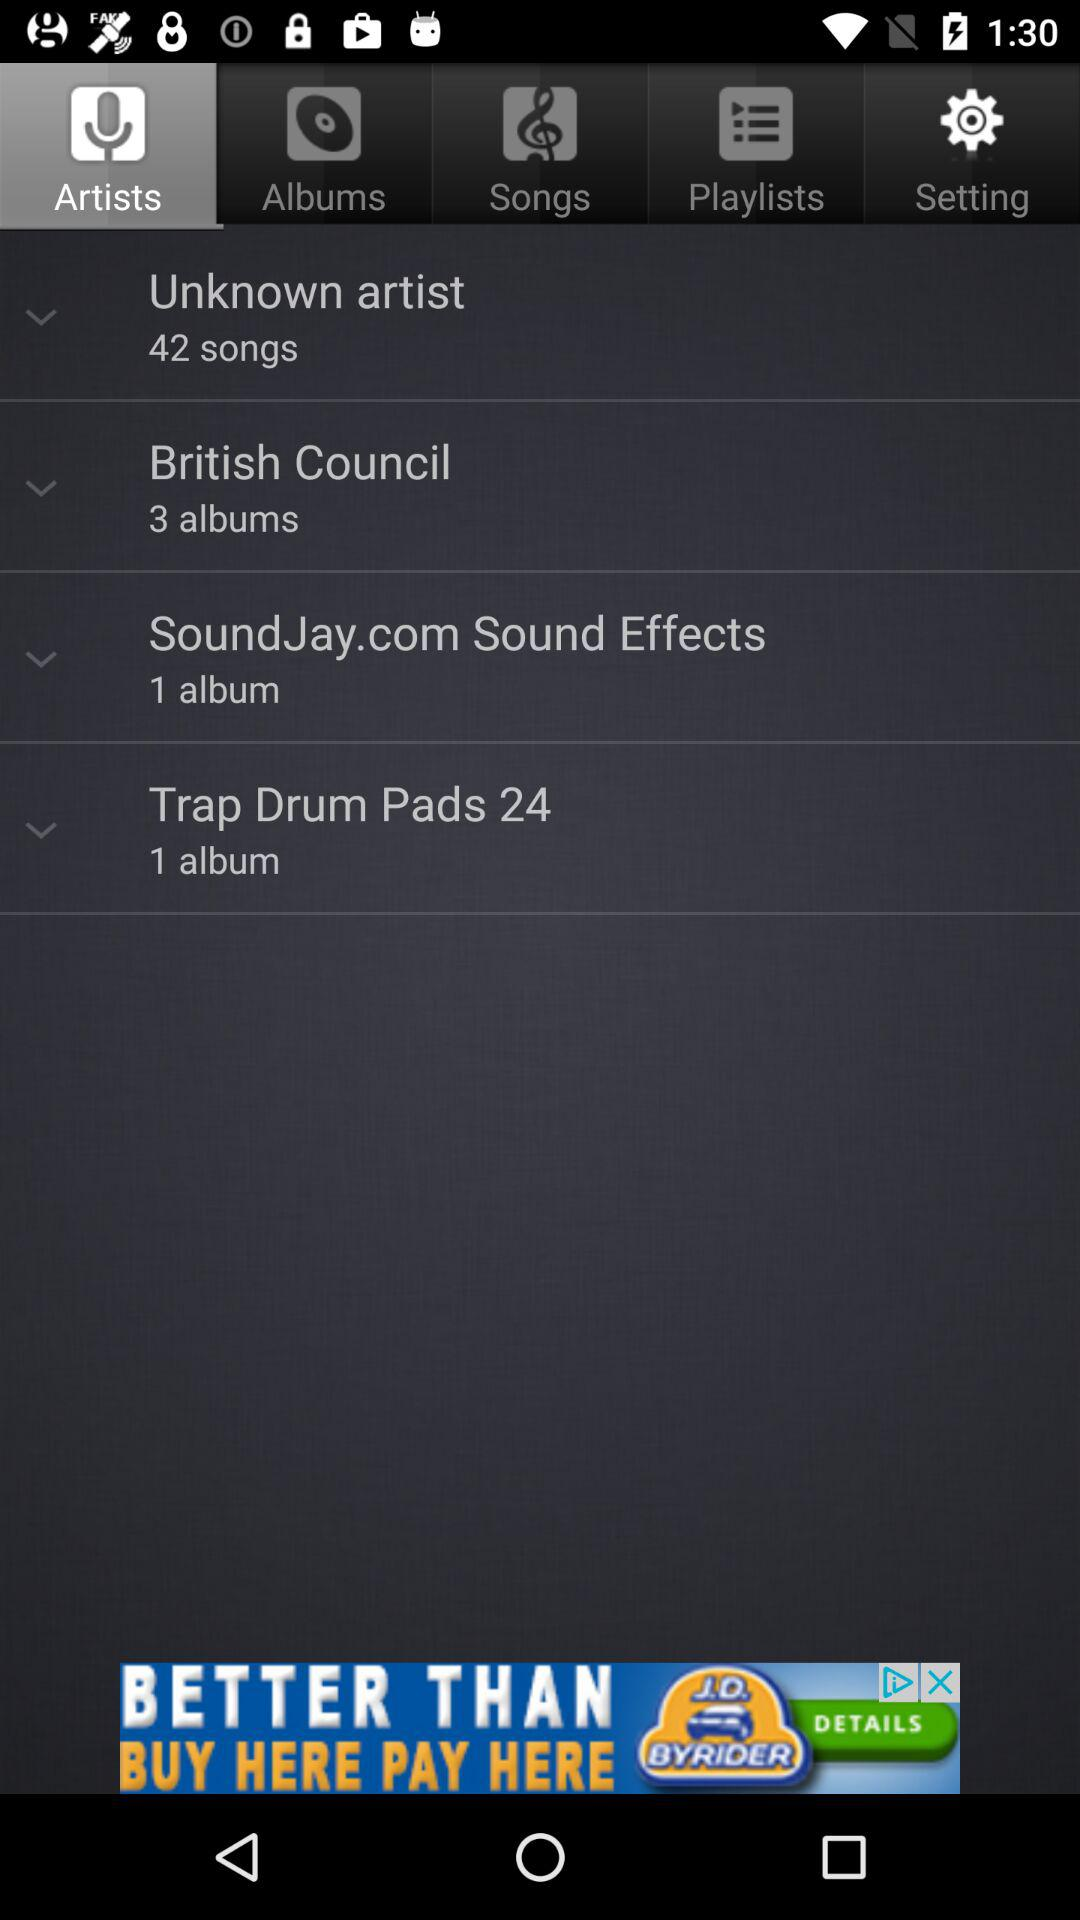What is the count of albums in "Trap Drum Pads 24"? There is 1 album in "Trap Drum Pads 24". 